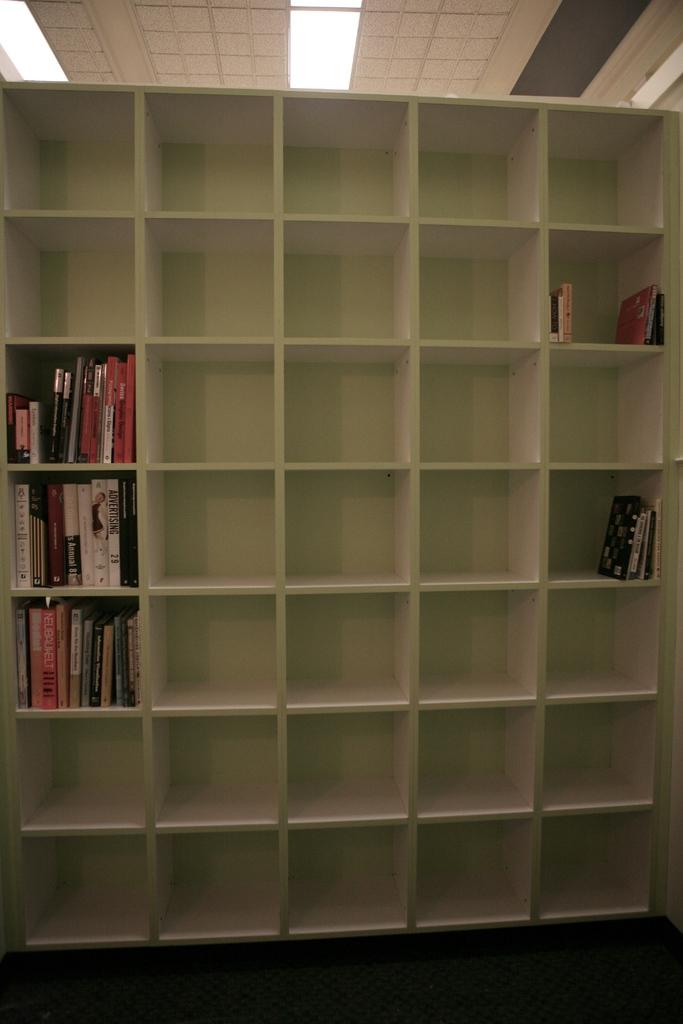What is located in the center of the image? There is a book rack in the center of the image. What is stored in the book rack? There are books in the book rack. What part of the room can be seen at the bottom of the image? The floor is visible at the bottom of the image. What part of the room can be seen at the top of the image? The ceiling is visible at the top of the image. What is present on the ceiling? There are lights on the ceiling. How does the book rack contribute to pollution in the image? The book rack does not contribute to pollution in the image; it is simply a storage unit for books. 